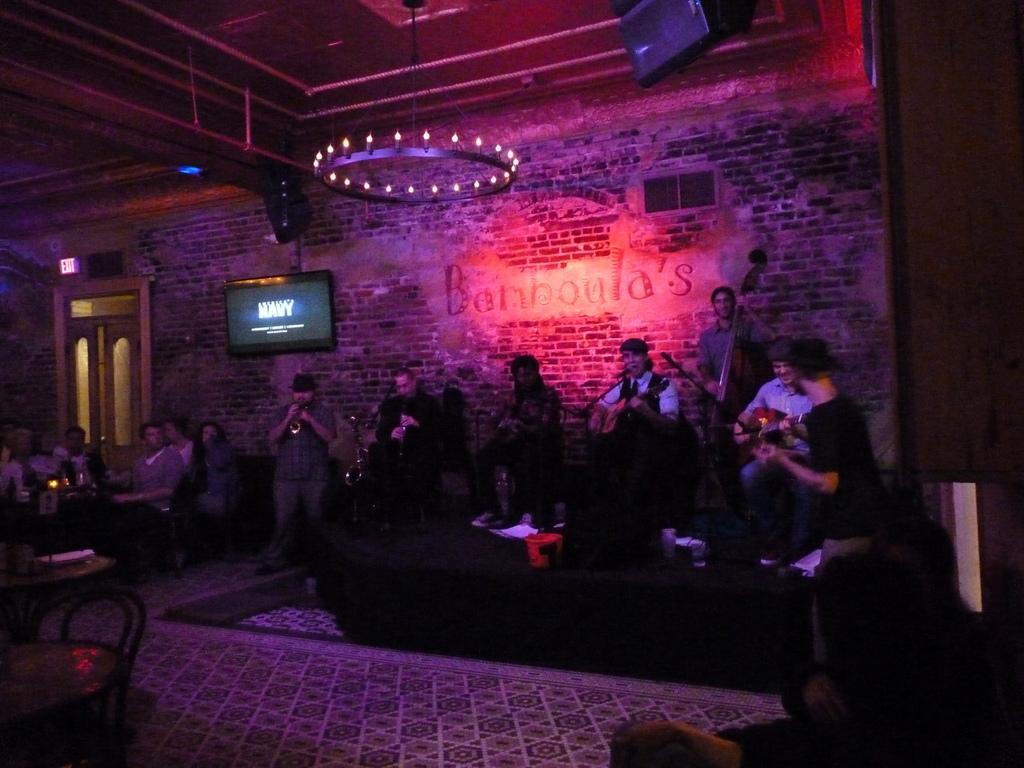Could you give a brief overview of what you see in this image? As we can see in the image there is wall, candles, screen, door, group of people, table and musical instruments. The image is little dark. 